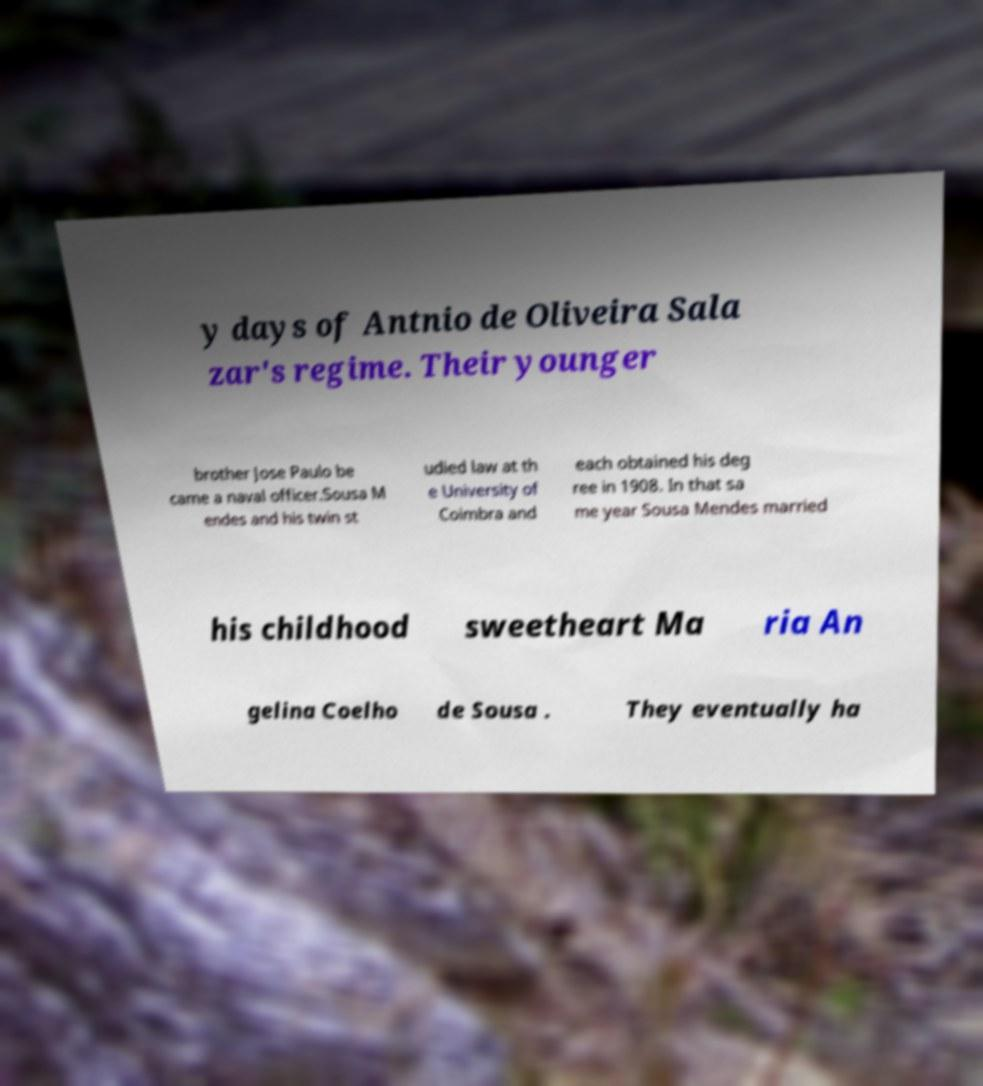For documentation purposes, I need the text within this image transcribed. Could you provide that? y days of Antnio de Oliveira Sala zar's regime. Their younger brother Jose Paulo be came a naval officer.Sousa M endes and his twin st udied law at th e University of Coimbra and each obtained his deg ree in 1908. In that sa me year Sousa Mendes married his childhood sweetheart Ma ria An gelina Coelho de Sousa . They eventually ha 